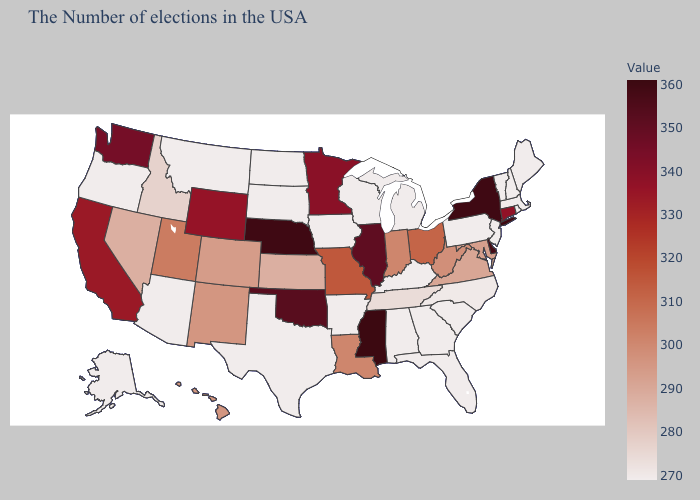Does Connecticut have the lowest value in the Northeast?
Give a very brief answer. No. Which states have the highest value in the USA?
Short answer required. Mississippi. Does Mississippi have the highest value in the USA?
Concise answer only. Yes. Does Mississippi have the highest value in the South?
Concise answer only. Yes. Among the states that border South Carolina , does North Carolina have the lowest value?
Concise answer only. No. Which states have the lowest value in the USA?
Quick response, please. Maine, Massachusetts, Rhode Island, New Hampshire, Vermont, New Jersey, Pennsylvania, South Carolina, Florida, Georgia, Michigan, Kentucky, Alabama, Wisconsin, Arkansas, Iowa, Texas, South Dakota, North Dakota, Montana, Arizona, Oregon, Alaska. Does California have a lower value than New Mexico?
Short answer required. No. 